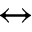Convert formula to latex. <formula><loc_0><loc_0><loc_500><loc_500>\leftrightarrow</formula> 